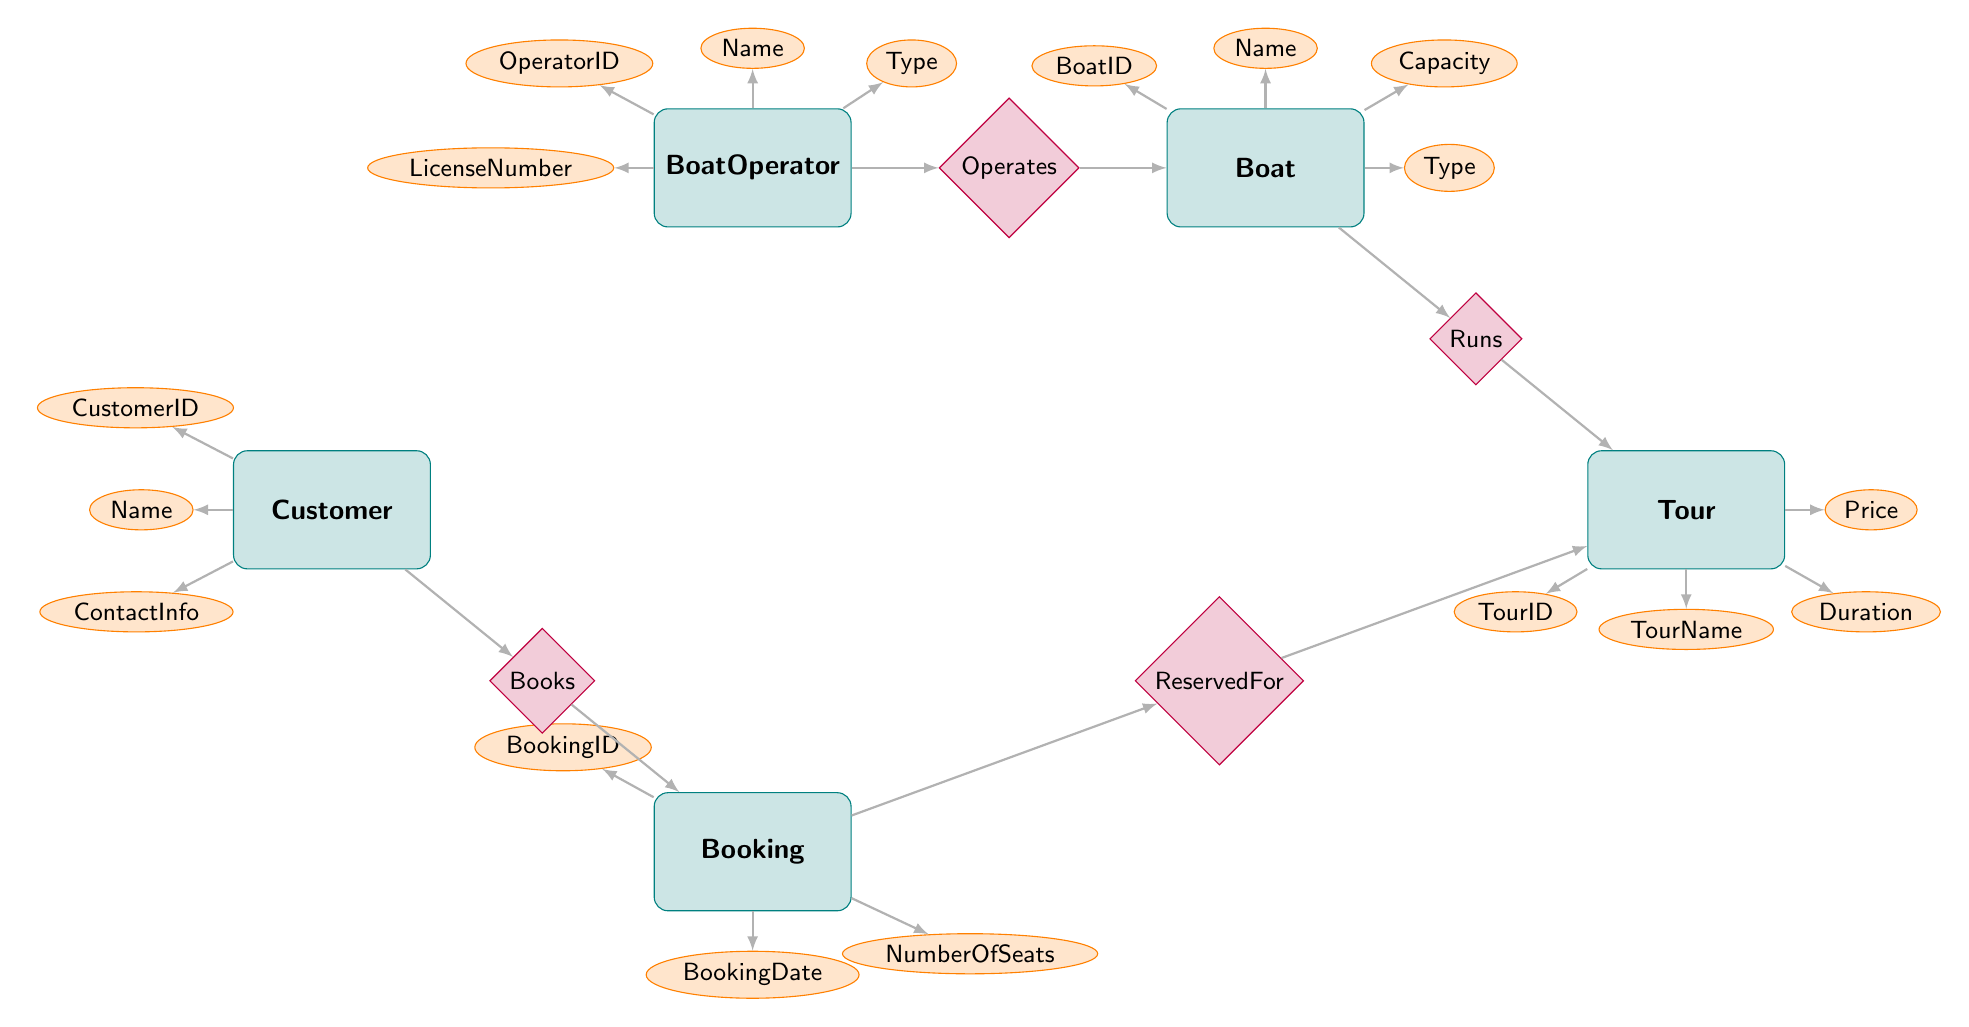What is the OperatorID attribute in the BoatOperator entity? The OperatorID attribute is one of the basic attributes listed directly within the BoatOperator entity in the diagram, which signifies the unique identifier for each boat operator.
Answer: OperatorID How many relationships are shown in the diagram? The diagram depicts four relationships connecting various entities. Each relationship is marked with a diamond shape, and there are exactly four distinct relationship connections.
Answer: 4 Which entity has the Runs relationship? The Runs relationship connects the Boat entity with the Tour entity. Therefore, looking at the connections in the diagram, the entity that has the Runs relationship directly is the Boat.
Answer: Boat What type of entity is Customer? The entity labeled Customer is classified as an entity and has attributes such as CustomerID, Name, and ContactInfo. The question regarding its type relates to its classification as a distinct entity in the diagram.
Answer: Entity If a Tour has the ID of 2, what would be the potential bookings associated with it? Based on the ReservedFor relationship between Booking and Tour, any Booking entity that refers back to TourID 2 would indicate a reservation connected to that Tour, thus providing its booked seats and customer details. However, specifics on these cannot be fully enumerated without additional data. Commonly, several bookings may be made against a single tour.
Answer: Multiple bookings What is the relationship between Customer and Booking? The relationship between the Customer and Booking entities is indicated by the Books relationship, which illustrates that a single customer can have several bookings or connections to bookings.
Answer: Books How many boats can one BoatOperator operate? Based on the 1 to Many relationship labeled Operates, one BoatOperator may operate multiple boats. Thus, the maximum is not specified as a fixed number but implies that it could be potentially high, as long as each operator can manage various boats.
Answer: Many boats What does the attribute NumberOfSeats refer to? The NumberOfSeats attribute is associated with the Booking entity, which indicates how many seats a customer is reserving for a specific tour. It is an integer value reflecting the capacity for a particular reservation made by a customer.
Answer: Number of seats reserved What is the TourID attribute? The TourID attribute is one of the identifying attributes within the Tour entity, serving as a unique identifier for each tour listed and helping to differentiate between different tours in the database.
Answer: TourID 